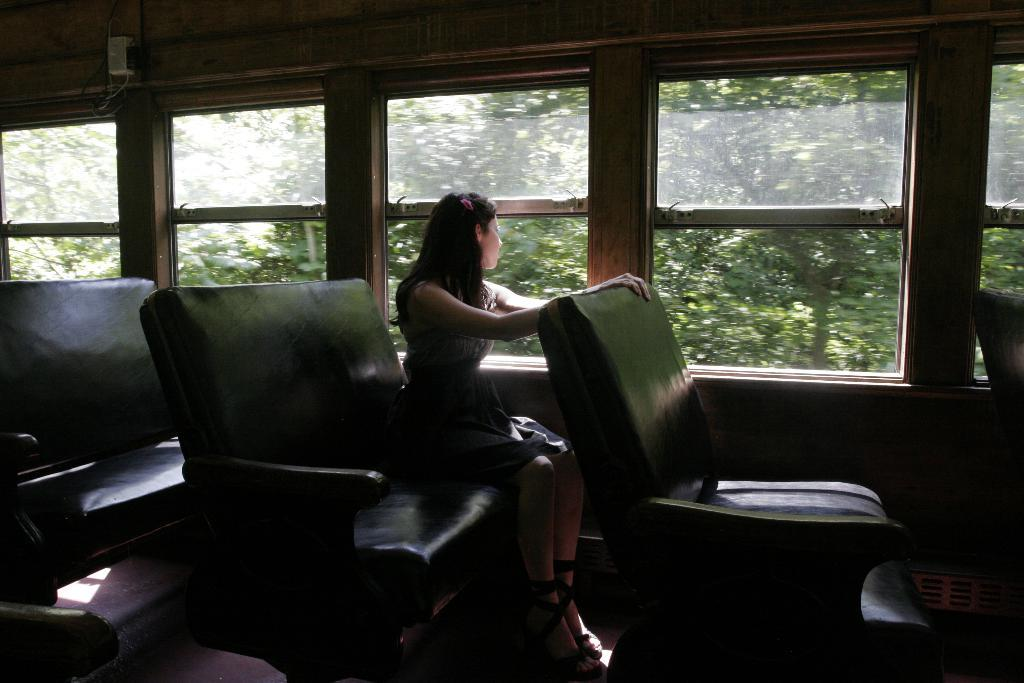What is the woman doing in the vehicle? The woman is sitting on a chair in the vehicle. What material are the windows made of in the vehicle? The windows in the vehicle are made of glass. What can be seen through the glass windows? Trees are visible through the glass windows. Is there any smoke coming from the vehicle in the image? There is no indication of smoke in the image; it only shows a woman sitting in a vehicle with glass windows and trees visible through them. 